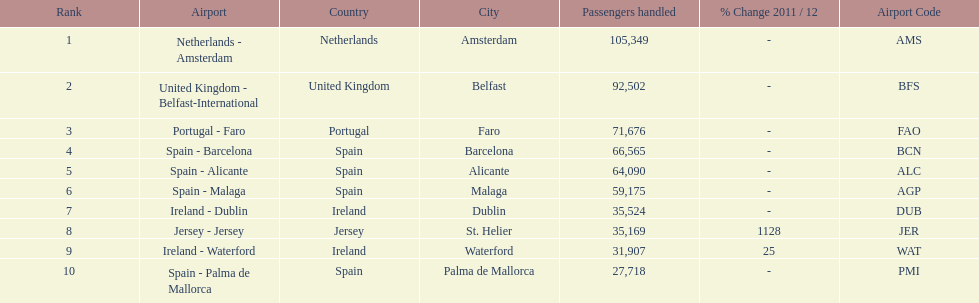How many airports are listed? 10. 